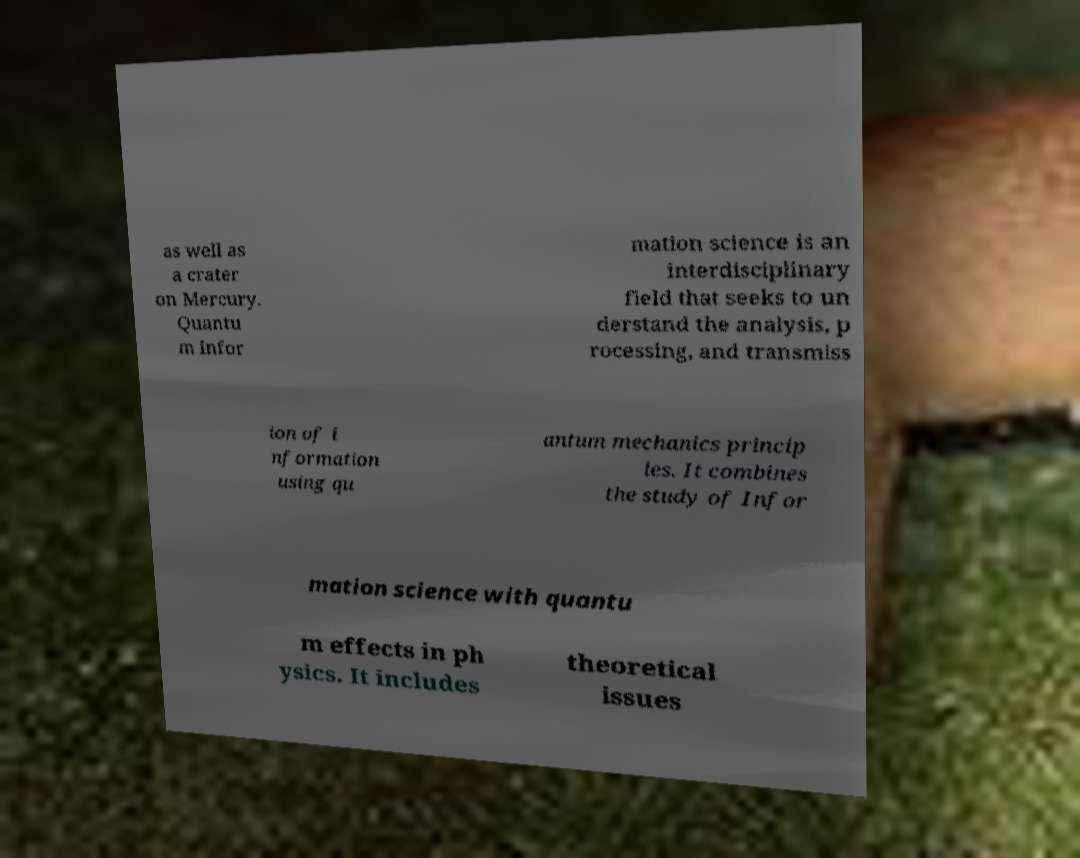Please read and relay the text visible in this image. What does it say? as well as a crater on Mercury. Quantu m infor mation science is an interdisciplinary field that seeks to un derstand the analysis, p rocessing, and transmiss ion of i nformation using qu antum mechanics princip les. It combines the study of Infor mation science with quantu m effects in ph ysics. It includes theoretical issues 